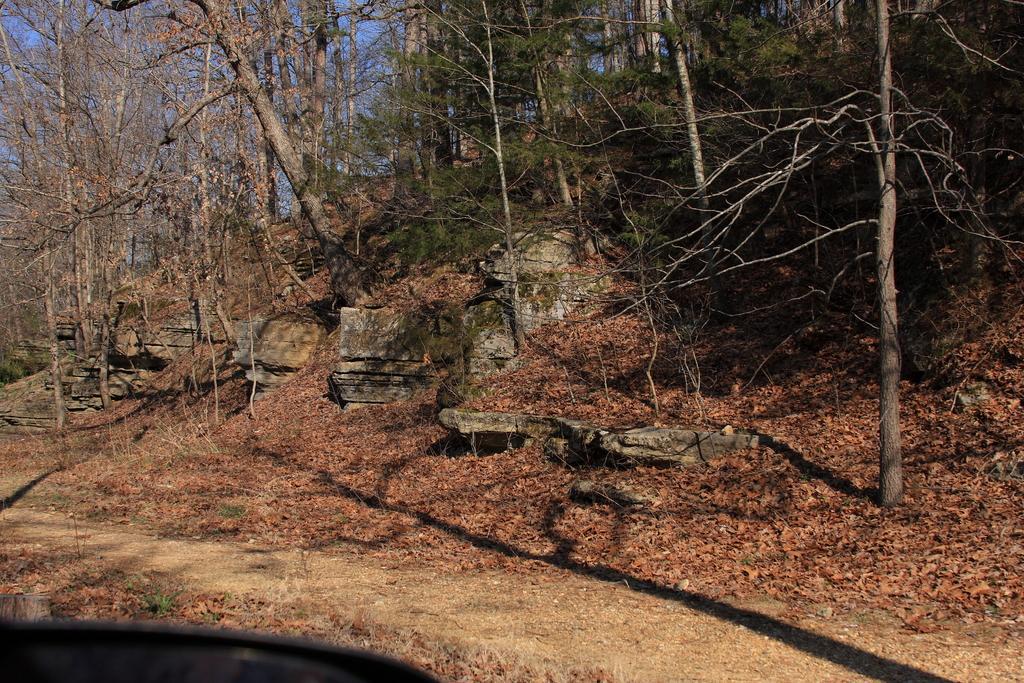Describe this image in one or two sentences. In this image we can see trees and there are rocks. At the bottom we can see shredded leaves. In the background there is sky. 